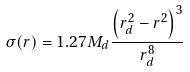<formula> <loc_0><loc_0><loc_500><loc_500>\sigma ( r ) = 1 . 2 7 M _ { d } \frac { \left ( r _ { d } ^ { 2 } - r ^ { 2 } \right ) ^ { 3 } } { r _ { d } ^ { 8 } }</formula> 